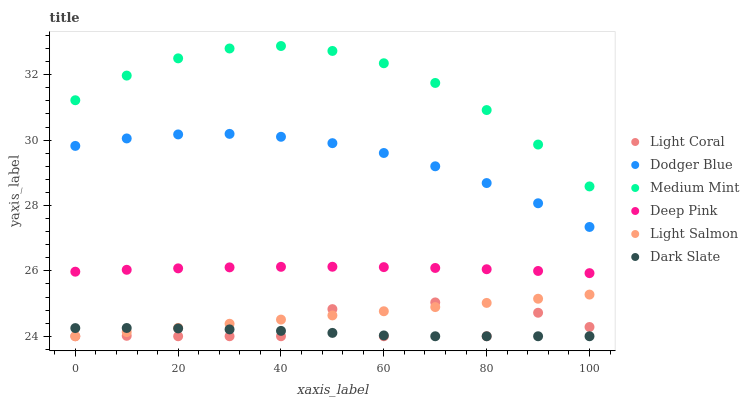Does Dark Slate have the minimum area under the curve?
Answer yes or no. Yes. Does Medium Mint have the maximum area under the curve?
Answer yes or no. Yes. Does Light Salmon have the minimum area under the curve?
Answer yes or no. No. Does Light Salmon have the maximum area under the curve?
Answer yes or no. No. Is Light Salmon the smoothest?
Answer yes or no. Yes. Is Light Coral the roughest?
Answer yes or no. Yes. Is Deep Pink the smoothest?
Answer yes or no. No. Is Deep Pink the roughest?
Answer yes or no. No. Does Light Salmon have the lowest value?
Answer yes or no. Yes. Does Deep Pink have the lowest value?
Answer yes or no. No. Does Medium Mint have the highest value?
Answer yes or no. Yes. Does Light Salmon have the highest value?
Answer yes or no. No. Is Light Salmon less than Dodger Blue?
Answer yes or no. Yes. Is Deep Pink greater than Light Coral?
Answer yes or no. Yes. Does Dark Slate intersect Light Coral?
Answer yes or no. Yes. Is Dark Slate less than Light Coral?
Answer yes or no. No. Is Dark Slate greater than Light Coral?
Answer yes or no. No. Does Light Salmon intersect Dodger Blue?
Answer yes or no. No. 